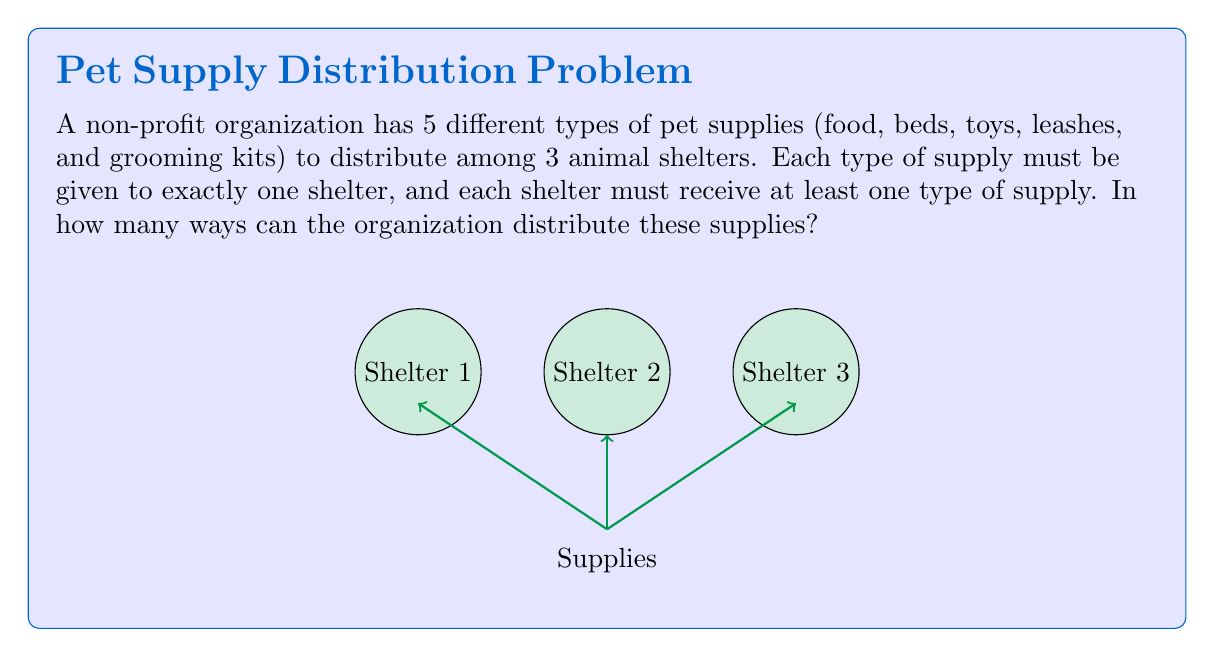Can you solve this math problem? Let's approach this step-by-step using the principle of inclusion-exclusion:

1) First, let's consider the total number of ways to distribute 5 supplies to 3 shelters without restrictions:
   $$3^5 = 243$$

2) However, we need to subtract the cases where at least one shelter receives no supplies. Let's calculate these:

   a) Number of ways where shelter 1 gets no supplies: $2^5 = 32$
   b) Number of ways where shelter 2 gets no supplies: $2^5 = 32$
   c) Number of ways where shelter 3 gets no supplies: $2^5 = 32$

3) But now we've double-counted some cases. We need to add back the cases where two shelters get no supplies:

   a) Shelters 1 and 2 get no supplies: $1^5 = 1$
   b) Shelters 1 and 3 get no supplies: $1^5 = 1$
   c) Shelters 2 and 3 get no supplies: $1^5 = 1$

4) We don't need to subtract the case where all three shelters get no supplies, as it's impossible with 5 supplies.

5) Applying the principle of inclusion-exclusion:

   $$\text{Total} = 3^5 - (3 \cdot 2^5) + (3 \cdot 1^5)$$
   $$= 243 - (3 \cdot 32) + 3$$
   $$= 243 - 96 + 3$$
   $$= 150$$

Therefore, there are 150 ways to distribute the supplies.
Answer: 150 